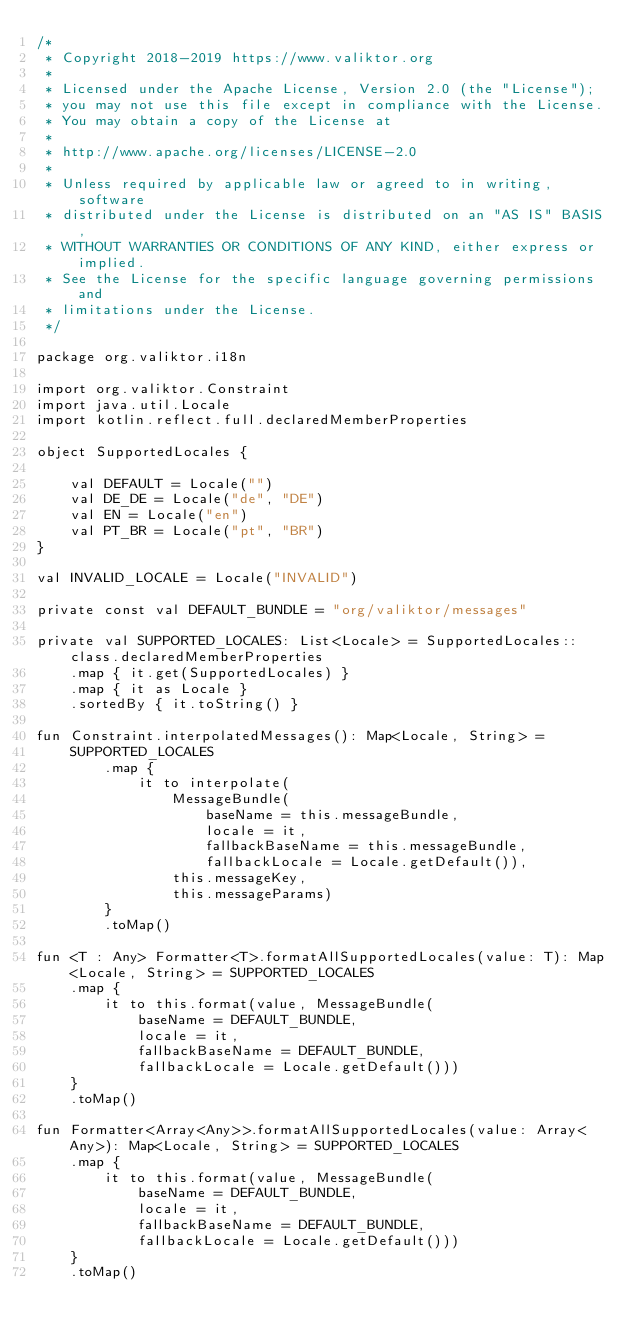Convert code to text. <code><loc_0><loc_0><loc_500><loc_500><_Kotlin_>/*
 * Copyright 2018-2019 https://www.valiktor.org
 *
 * Licensed under the Apache License, Version 2.0 (the "License");
 * you may not use this file except in compliance with the License.
 * You may obtain a copy of the License at
 *
 * http://www.apache.org/licenses/LICENSE-2.0
 *
 * Unless required by applicable law or agreed to in writing, software
 * distributed under the License is distributed on an "AS IS" BASIS,
 * WITHOUT WARRANTIES OR CONDITIONS OF ANY KIND, either express or implied.
 * See the License for the specific language governing permissions and
 * limitations under the License.
 */

package org.valiktor.i18n

import org.valiktor.Constraint
import java.util.Locale
import kotlin.reflect.full.declaredMemberProperties

object SupportedLocales {

    val DEFAULT = Locale("")
    val DE_DE = Locale("de", "DE")
    val EN = Locale("en")
    val PT_BR = Locale("pt", "BR")
}

val INVALID_LOCALE = Locale("INVALID")

private const val DEFAULT_BUNDLE = "org/valiktor/messages"

private val SUPPORTED_LOCALES: List<Locale> = SupportedLocales::class.declaredMemberProperties
    .map { it.get(SupportedLocales) }
    .map { it as Locale }
    .sortedBy { it.toString() }

fun Constraint.interpolatedMessages(): Map<Locale, String> =
    SUPPORTED_LOCALES
        .map {
            it to interpolate(
                MessageBundle(
                    baseName = this.messageBundle,
                    locale = it,
                    fallbackBaseName = this.messageBundle,
                    fallbackLocale = Locale.getDefault()),
                this.messageKey,
                this.messageParams)
        }
        .toMap()

fun <T : Any> Formatter<T>.formatAllSupportedLocales(value: T): Map<Locale, String> = SUPPORTED_LOCALES
    .map {
        it to this.format(value, MessageBundle(
            baseName = DEFAULT_BUNDLE,
            locale = it,
            fallbackBaseName = DEFAULT_BUNDLE,
            fallbackLocale = Locale.getDefault()))
    }
    .toMap()

fun Formatter<Array<Any>>.formatAllSupportedLocales(value: Array<Any>): Map<Locale, String> = SUPPORTED_LOCALES
    .map {
        it to this.format(value, MessageBundle(
            baseName = DEFAULT_BUNDLE,
            locale = it,
            fallbackBaseName = DEFAULT_BUNDLE,
            fallbackLocale = Locale.getDefault()))
    }
    .toMap()</code> 